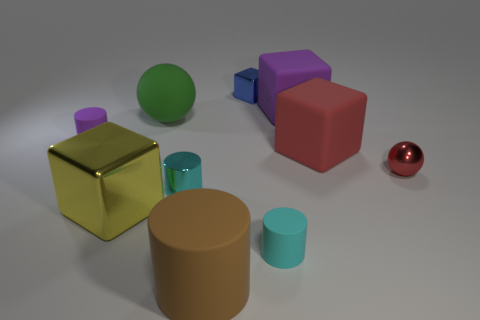There is a metallic object that is the same size as the brown matte thing; what is its shape?
Ensure brevity in your answer.  Cube. What shape is the cyan object in front of the big cube that is on the left side of the green sphere?
Provide a short and direct response. Cylinder. Are there any metallic spheres in front of the tiny shiny cylinder?
Your answer should be very brief. No. What color is the shiny cube that is left of the tiny cyan thing left of the tiny blue object?
Provide a succinct answer. Yellow. Are there fewer tiny cyan matte objects than small rubber objects?
Offer a very short reply. Yes. What number of large things have the same shape as the tiny red object?
Offer a very short reply. 1. What color is the metal sphere that is the same size as the blue metal block?
Offer a terse response. Red. Is the number of tiny cyan metal things in front of the green rubber object the same as the number of brown rubber cylinders that are left of the tiny cube?
Make the answer very short. Yes. Is there a yellow metallic object that has the same size as the brown matte object?
Your answer should be very brief. Yes. The green ball is what size?
Provide a succinct answer. Large. 